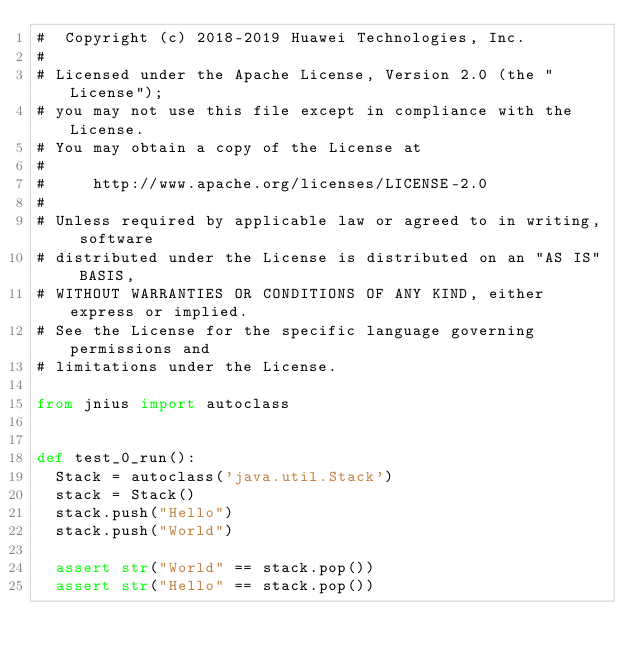<code> <loc_0><loc_0><loc_500><loc_500><_Python_>#  Copyright (c) 2018-2019 Huawei Technologies, Inc.
#
# Licensed under the Apache License, Version 2.0 (the "License");
# you may not use this file except in compliance with the License.
# You may obtain a copy of the License at
#
#     http://www.apache.org/licenses/LICENSE-2.0
#
# Unless required by applicable law or agreed to in writing, software
# distributed under the License is distributed on an "AS IS" BASIS,
# WITHOUT WARRANTIES OR CONDITIONS OF ANY KIND, either express or implied.
# See the License for the specific language governing permissions and
# limitations under the License.

from jnius import autoclass


def test_0_run():
  Stack = autoclass('java.util.Stack')
  stack = Stack()
  stack.push("Hello")
  stack.push("World")

  assert str("World" == stack.pop())
  assert str("Hello" == stack.pop())
</code> 